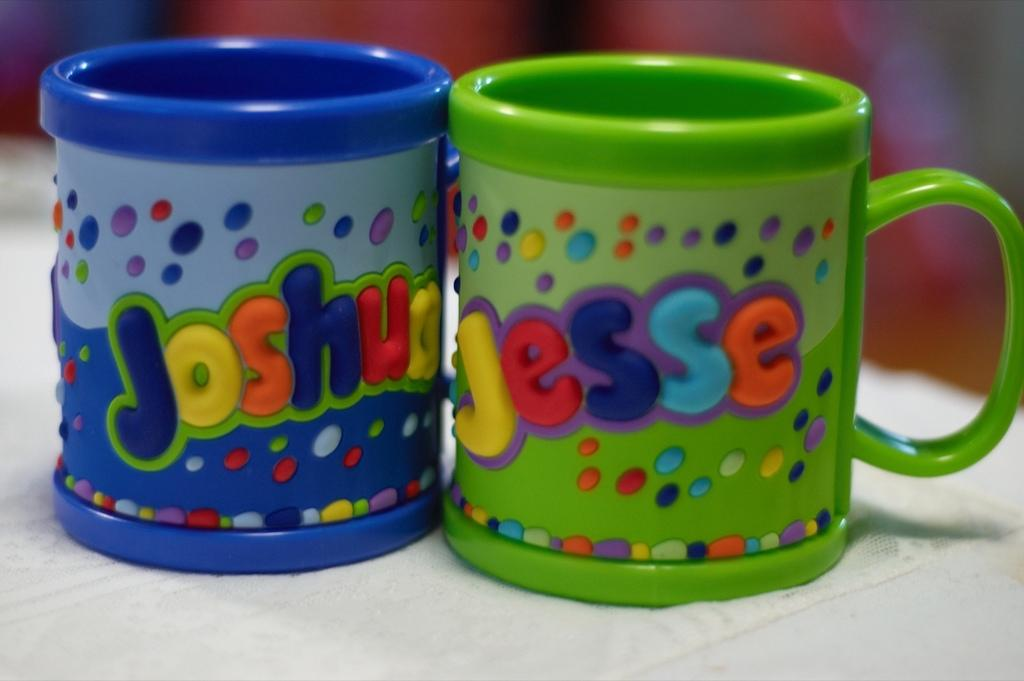<image>
Describe the image concisely. Two colorful children's mugs with the names Joshua and Jesse. 